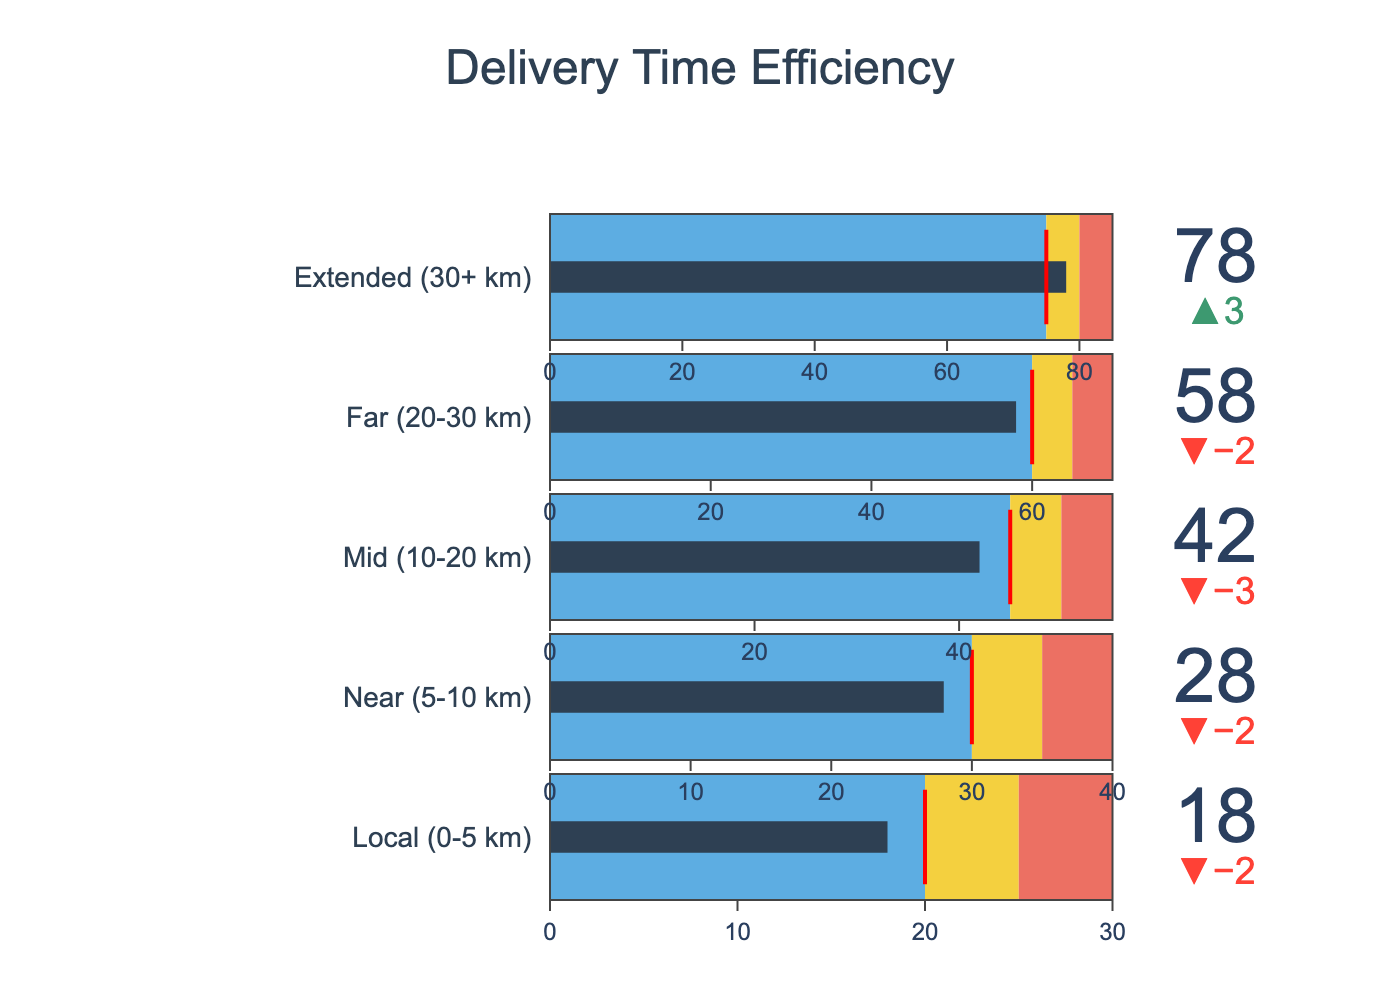what is the title of the chart? The title is located at the top of the figure and is usually more prominent in size and style compared to other text elements. Look at the highest part of the figure to find it.
Answer: Delivery Time Efficiency how many distance zones are represented in this chart? The number of distance zones can be counted by looking at the number of separate indicator titles. Each title corresponds to a different distance zone.
Answer: 5 what is the 'actual time' for the 'near' delivery zone? Locate the 'Near (5-10 km)' section in the bullet chart and read the value labeled 'Actual Time (mins)'.
Answer: 28 which delivery zone is performing the best relative to its target time? Performance relative to target time can be evaluated by the delta between actual time and target time. The zone with the smallest positive or the largest negative delta is performing the best.
Answer: Local (0-5 km) which delivery zone's actual time is beyond the urgent threshold? Compare the 'Actual Time (mins)' with the 'Urgent Threshold (mins)' for each delivery zone. Identify the zones where the actual time exceeds the urgent threshold.
Answer: Extended (30+ km) what is the target time for the 'far' delivery zone? Locate the 'Far (20-30 km)' section in the bullet chart and find the value labeled 'Target Time (mins)'.
Answer: 60 by how many minutes does the 'mid' delivery zone exceed its caution threshold? Find the difference between 'Actual Time (mins)' and 'Caution Threshold (mins)' for the 'Mid (10-20 km)' zone. Calculate this as 42 - 50.
Answer: 7 minutes what are the color codes representing different performance levels in the bullet chart? Observe the legend or the variations in the bar colors within each bullet. The colors for performance levels are typically set as different shades for different ranges. #5DADE2 for good, #F4D03F for caution, and #EC7063 for urgent.
Answer: #5DADE2, #F4D03F, #EC7063 which delivery zone is closest to its target time? Locate each delivery zone and calculate the delta between 'Actual Time (mins)' and 'Target Time (mins)'. The zone with the smallest absolute delta is the closest to its target time.
Answer: Local (0-5 km) what does the red line represent in each bullet chart? In bullet charts, a red line is typically used to indicate the target or a significant threshold. By examining the legend and bullet details, the red line represents the target time.
Answer: Target Time 